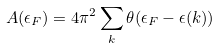<formula> <loc_0><loc_0><loc_500><loc_500>A ( \epsilon _ { F } ) = 4 \pi ^ { 2 } \sum _ { k } \theta ( \epsilon _ { F } - \epsilon ( { k } ) )</formula> 